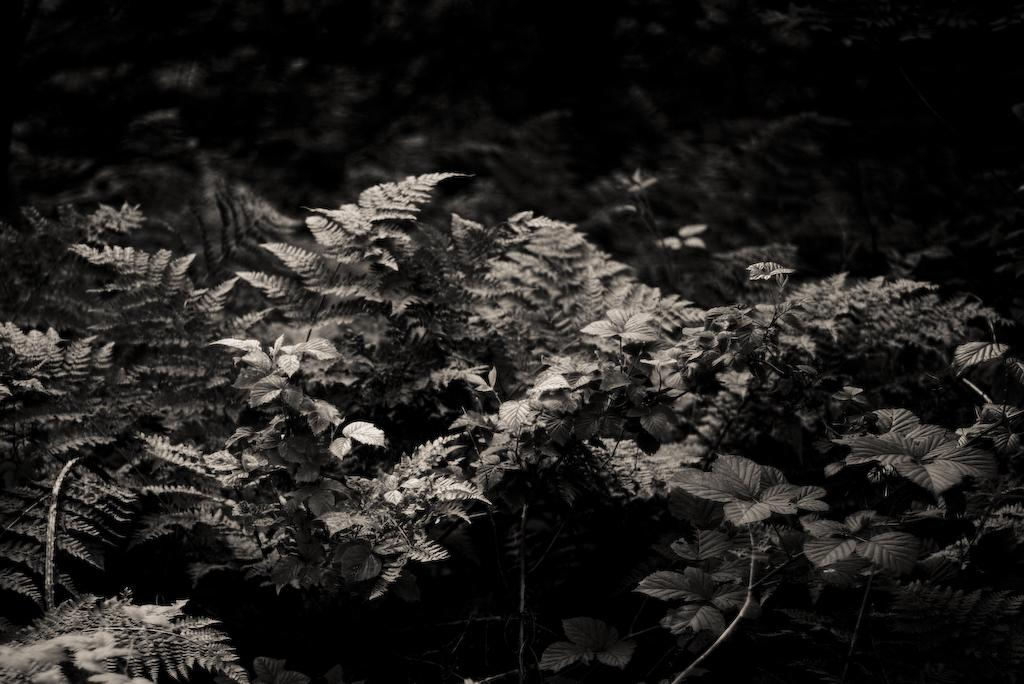What type of living organisms can be seen in the image? Plants can be seen in the image. What type of shirt is the plant wearing in the image? There is no shirt present in the image, as plants do not wear clothing. 